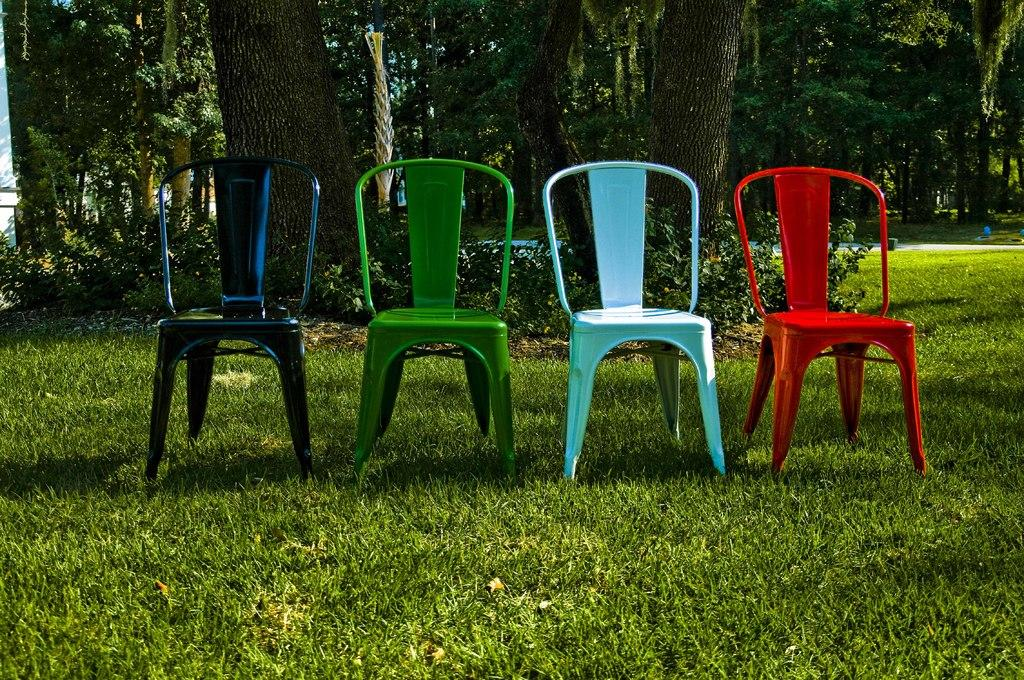How many chairs are in the image? There are four chairs in the image. Where are the chairs located? The chairs are on the grass. What colors are the chairs? The chairs are black, green, powder blue, and red. What can be seen in the background of the image? There are trees in the background of the image. What type of produce can be seen growing on the chairs in the image? There is no produce growing on the chairs in the image; they are chairs placed on the grass. 